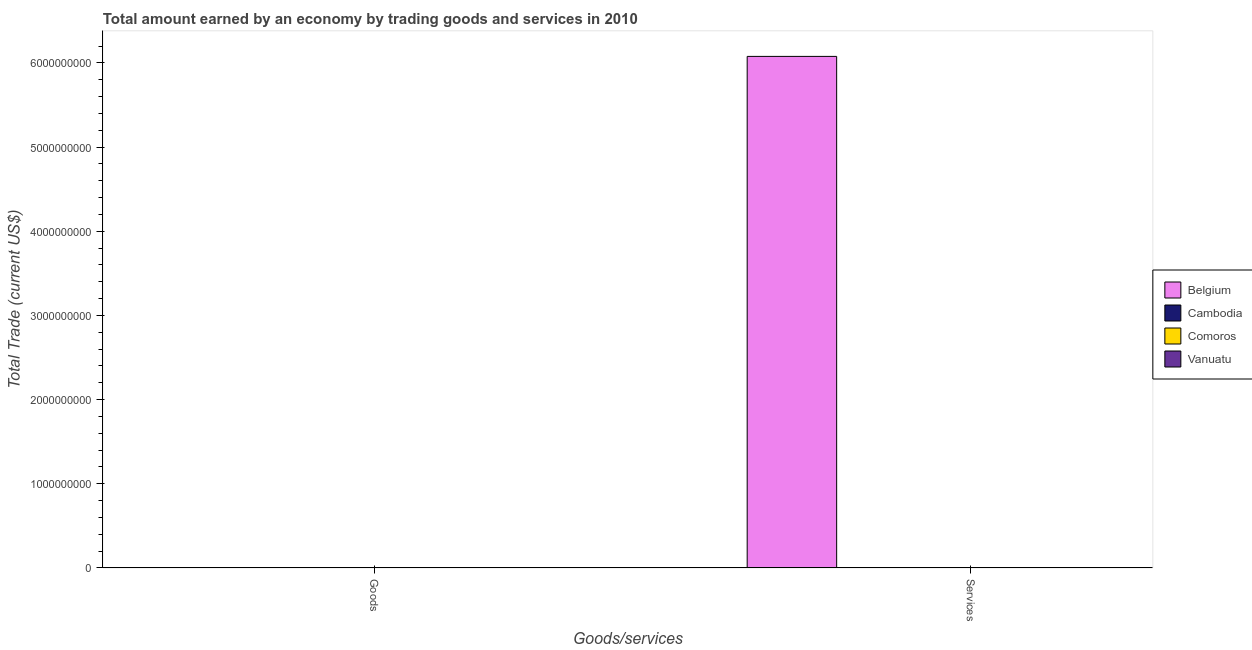Are the number of bars per tick equal to the number of legend labels?
Your response must be concise. No. Are the number of bars on each tick of the X-axis equal?
Give a very brief answer. No. How many bars are there on the 2nd tick from the right?
Give a very brief answer. 0. What is the label of the 2nd group of bars from the left?
Provide a succinct answer. Services. What is the amount earned by trading goods in Vanuatu?
Give a very brief answer. 0. Across all countries, what is the maximum amount earned by trading services?
Make the answer very short. 6.08e+09. Across all countries, what is the minimum amount earned by trading services?
Provide a succinct answer. 0. What is the total amount earned by trading services in the graph?
Your answer should be compact. 6.08e+09. What is the average amount earned by trading services per country?
Your response must be concise. 1.52e+09. In how many countries, is the amount earned by trading services greater than 3000000000 US$?
Provide a short and direct response. 1. How many bars are there?
Keep it short and to the point. 1. Are all the bars in the graph horizontal?
Your answer should be very brief. No. How many countries are there in the graph?
Ensure brevity in your answer.  4. Are the values on the major ticks of Y-axis written in scientific E-notation?
Provide a short and direct response. No. Does the graph contain any zero values?
Make the answer very short. Yes. Does the graph contain grids?
Give a very brief answer. No. Where does the legend appear in the graph?
Make the answer very short. Center right. How are the legend labels stacked?
Provide a succinct answer. Vertical. What is the title of the graph?
Your response must be concise. Total amount earned by an economy by trading goods and services in 2010. What is the label or title of the X-axis?
Ensure brevity in your answer.  Goods/services. What is the label or title of the Y-axis?
Your response must be concise. Total Trade (current US$). What is the Total Trade (current US$) in Belgium in Goods?
Provide a short and direct response. 0. What is the Total Trade (current US$) of Belgium in Services?
Your answer should be very brief. 6.08e+09. What is the Total Trade (current US$) of Comoros in Services?
Offer a very short reply. 0. Across all Goods/services, what is the maximum Total Trade (current US$) of Belgium?
Your response must be concise. 6.08e+09. What is the total Total Trade (current US$) in Belgium in the graph?
Offer a terse response. 6.08e+09. What is the average Total Trade (current US$) in Belgium per Goods/services?
Keep it short and to the point. 3.04e+09. What is the average Total Trade (current US$) of Cambodia per Goods/services?
Give a very brief answer. 0. What is the difference between the highest and the lowest Total Trade (current US$) of Belgium?
Ensure brevity in your answer.  6.08e+09. 